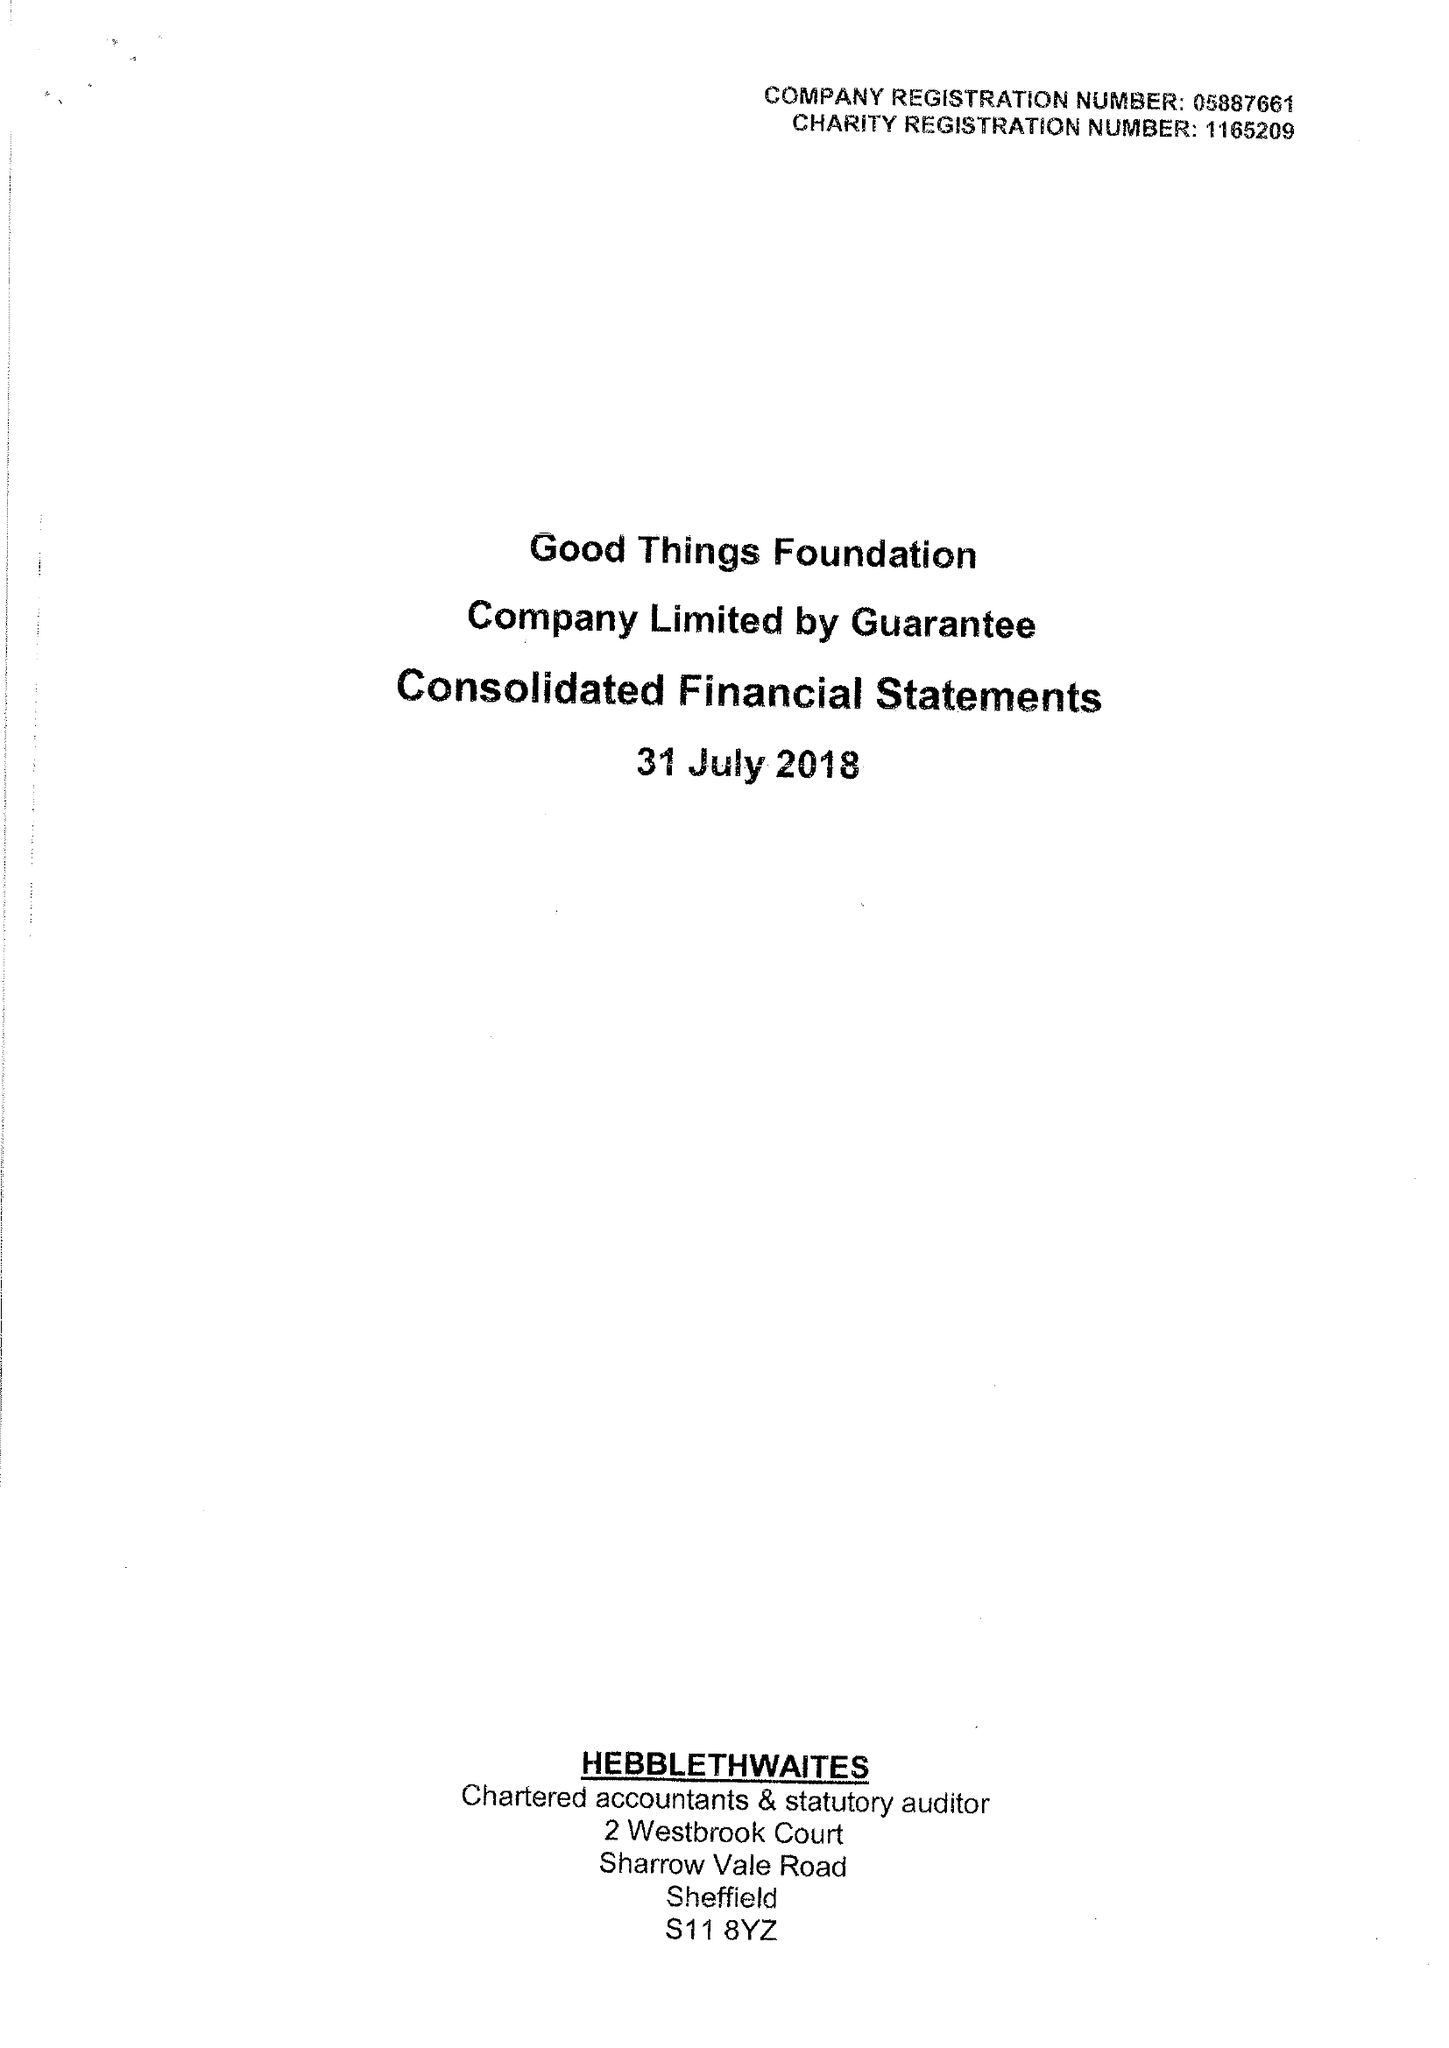What is the value for the address__post_town?
Answer the question using a single word or phrase. SHEFFIELD 